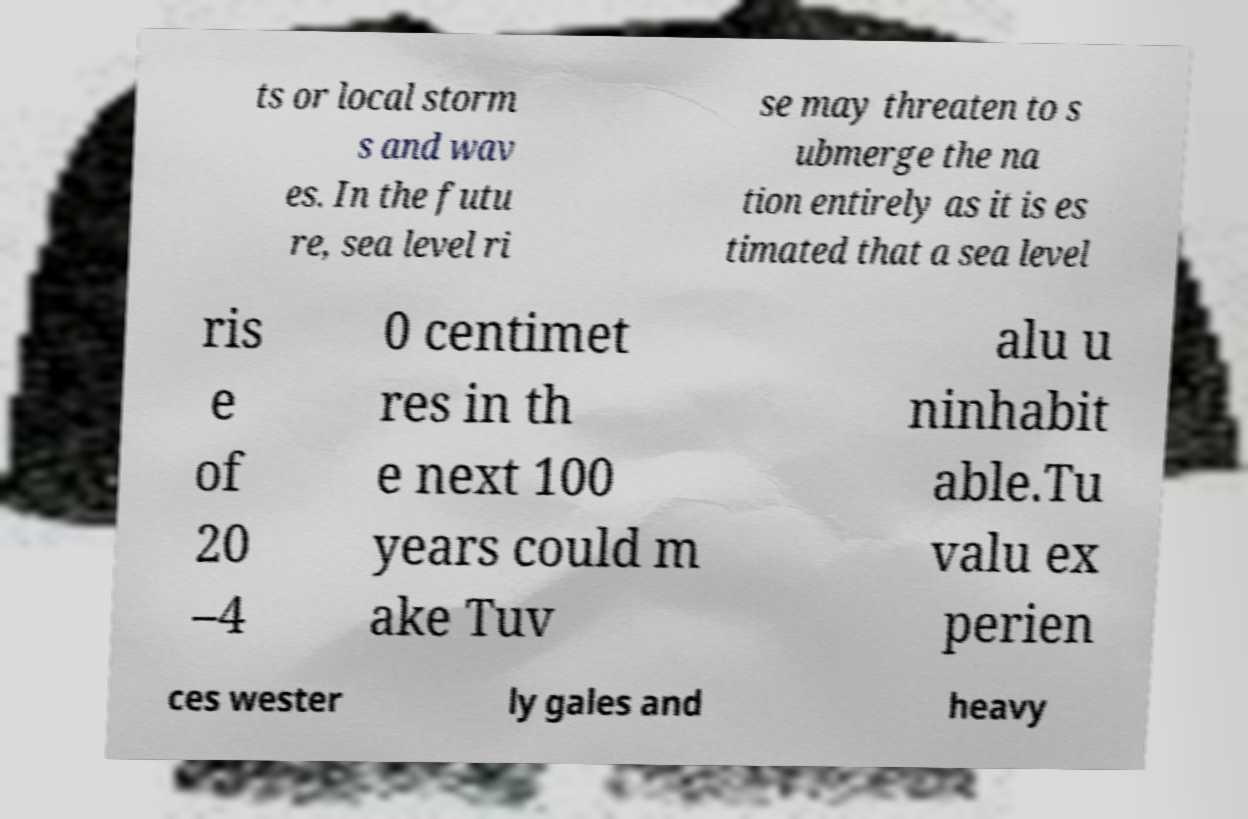Please identify and transcribe the text found in this image. ts or local storm s and wav es. In the futu re, sea level ri se may threaten to s ubmerge the na tion entirely as it is es timated that a sea level ris e of 20 –4 0 centimet res in th e next 100 years could m ake Tuv alu u ninhabit able.Tu valu ex perien ces wester ly gales and heavy 